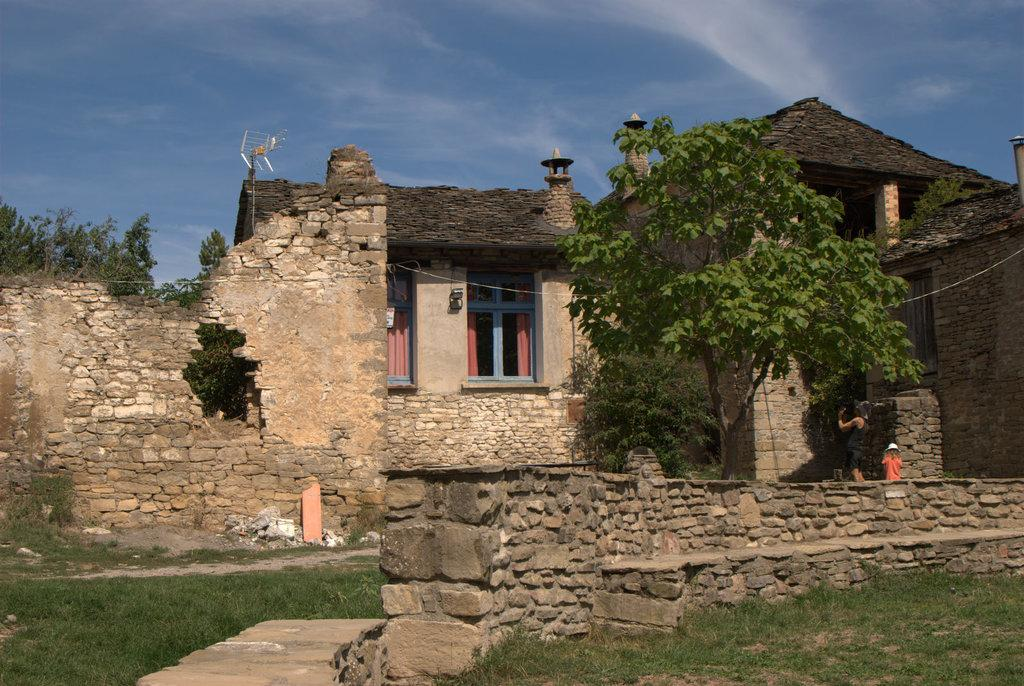What type of structures can be seen in the image? There are buildings in the image. Can you describe the person in the image? There is a person standing on the right side of the image. What type of vegetation is present in the image? There are trees in the image. What is the condition of the sky in the image? The sky is clear in the backdrop of the image. What color is the brain of the person standing on the right side of the image? There is no brain visible in the image; it is a person standing on the right side. How many wings can be seen on the trees in the image? Trees do not have wings, so this question cannot be answered based on the image. 